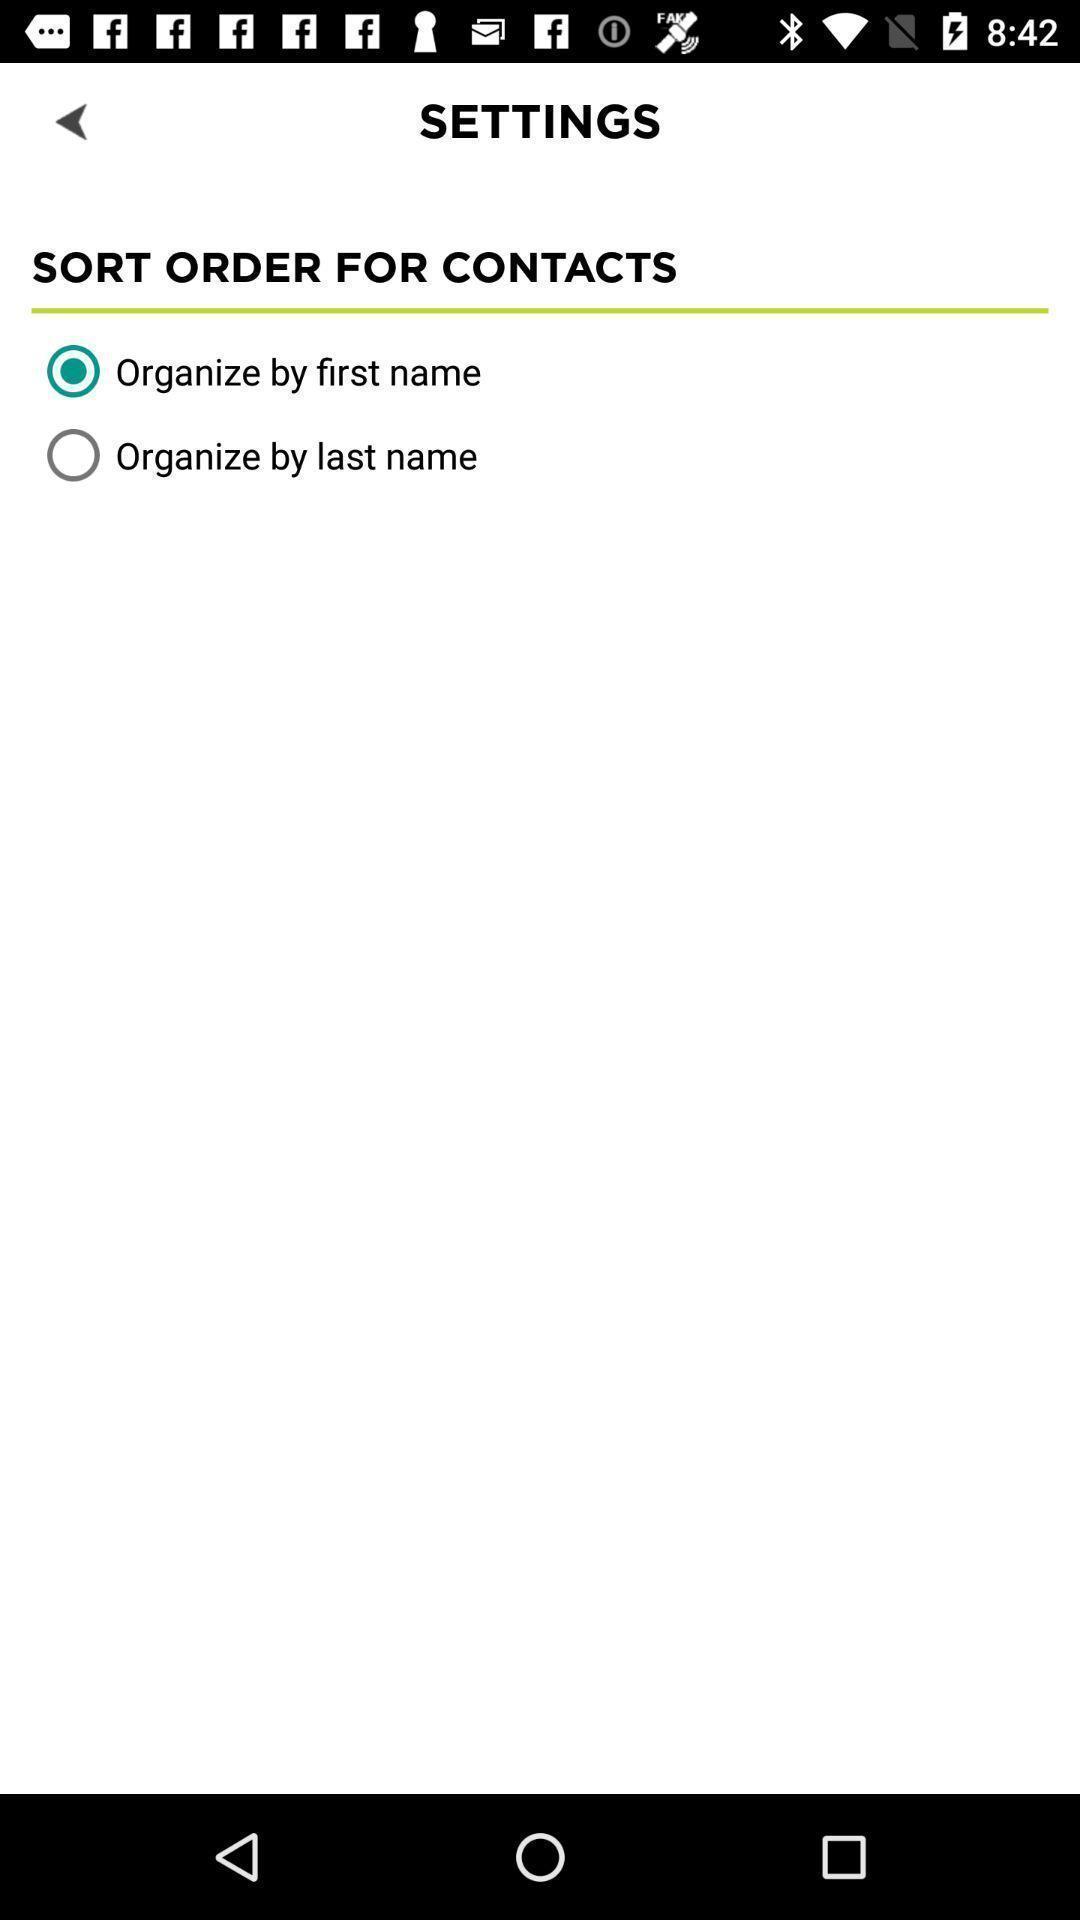Please provide a description for this image. Setting page showing in application. 